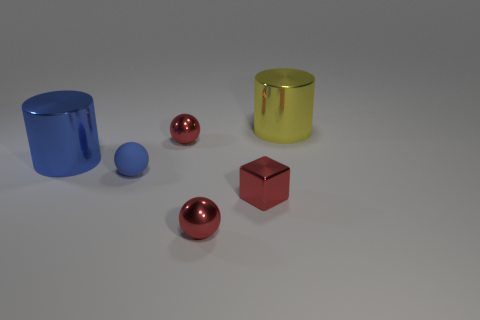There is a tiny metallic sphere behind the large blue object; what is its color?
Offer a terse response. Red. What is the color of the other large thing that is the same shape as the blue metal object?
Provide a short and direct response. Yellow. Is there anything else of the same color as the rubber ball?
Offer a very short reply. Yes. Are there more red metallic spheres than things?
Offer a terse response. No. Is the material of the big blue thing the same as the small red block?
Your answer should be very brief. Yes. How many balls have the same material as the tiny red cube?
Offer a terse response. 2. There is a blue matte thing; is its size the same as the red shiny sphere behind the small red metal block?
Offer a very short reply. Yes. The small sphere that is both in front of the big blue shiny thing and to the right of the tiny blue ball is what color?
Your answer should be compact. Red. Is there a large thing that is on the left side of the metallic cylinder that is on the right side of the tiny matte thing?
Give a very brief answer. Yes. Are there the same number of yellow metallic things that are to the right of the big yellow metallic object and tiny blue matte objects?
Your response must be concise. No. 